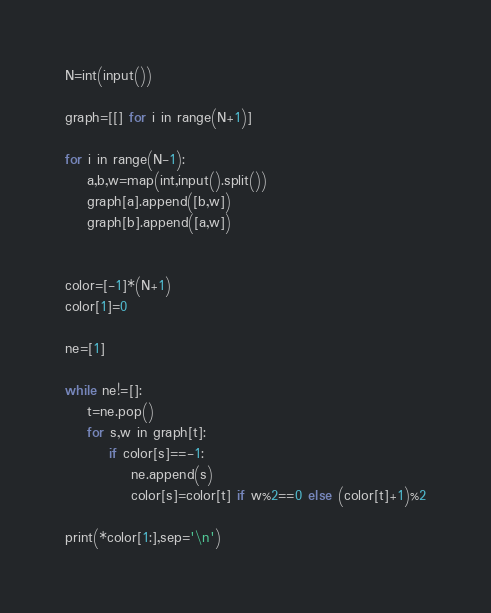<code> <loc_0><loc_0><loc_500><loc_500><_Python_>N=int(input())

graph=[[] for i in range(N+1)]

for i in range(N-1):
	a,b,w=map(int,input().split())
	graph[a].append([b,w])
	graph[b].append([a,w])


color=[-1]*(N+1)
color[1]=0

ne=[1]

while ne!=[]:
	t=ne.pop()
	for s,w in graph[t]:
		if color[s]==-1:
			ne.append(s)
			color[s]=color[t] if w%2==0 else (color[t]+1)%2

print(*color[1:],sep='\n')
</code> 